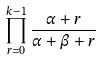<formula> <loc_0><loc_0><loc_500><loc_500>\prod _ { r = 0 } ^ { k - 1 } \frac { \alpha + r } { \alpha + \beta + r }</formula> 